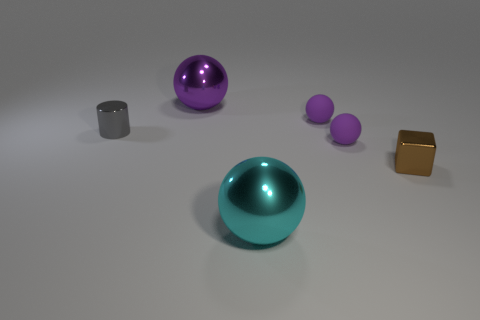Subtract all purple balls. How many were subtracted if there are1purple balls left? 2 Subtract all purple blocks. How many purple balls are left? 3 Subtract all cyan spheres. How many spheres are left? 3 Subtract all cyan spheres. How many spheres are left? 3 Subtract all yellow balls. Subtract all cyan cylinders. How many balls are left? 4 Add 3 blue things. How many objects exist? 9 Subtract 3 purple spheres. How many objects are left? 3 Subtract all cubes. How many objects are left? 5 Subtract all cyan cylinders. Subtract all small purple balls. How many objects are left? 4 Add 3 purple shiny things. How many purple shiny things are left? 4 